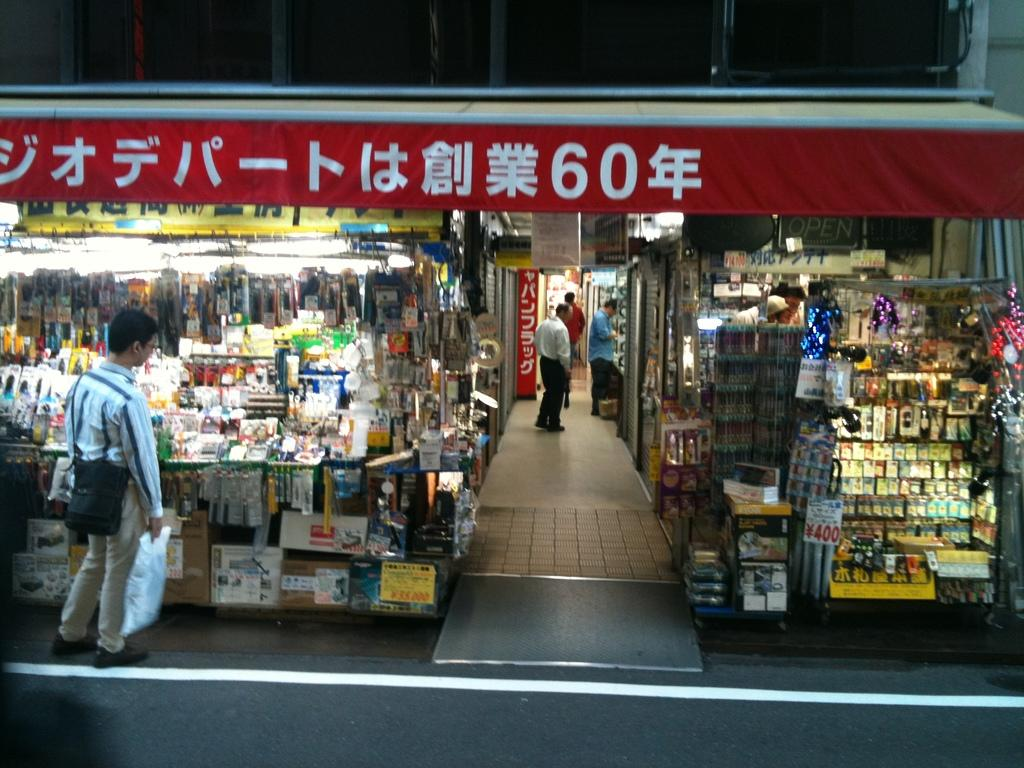<image>
Present a compact description of the photo's key features. A shop has the number 60 on its red awning. 